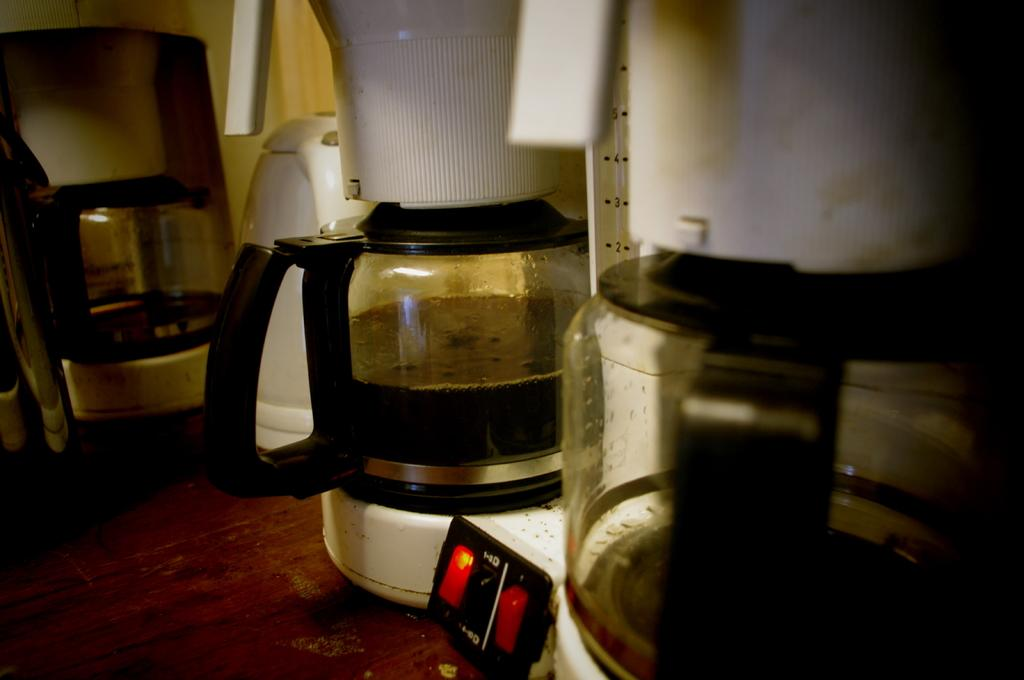What appliances are on the table in the image? There are two mixers on a table in the image. What object in the image can be used to turn something on or off? There is a switch in the image that can be used to turn something on or off. What type of container is visible in the image? There is a jar in the image. How does the mixer rest on the table in the image? The mixers are not resting on the table; they are standing upright. What is the taste of the mixer in the image? Mixers do not have a taste, as they are appliances and not food items. 